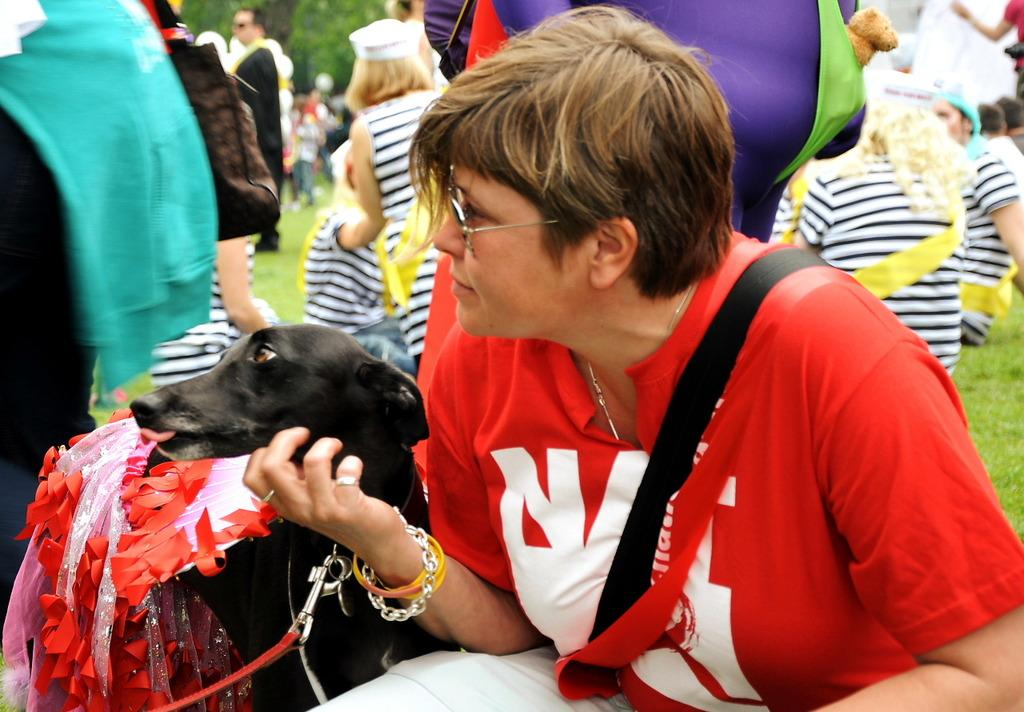What can be seen in the image involving multiple individuals? There is a group of people in the image. Can you describe the woman in the image? The woman in the image is wearing a bag. What is the setting of the image? There is a dog in the garden. What type of appliance can be seen in the image? There is no appliance present in the image. Is there a zebra in the image? No, there is no zebra in the image. 